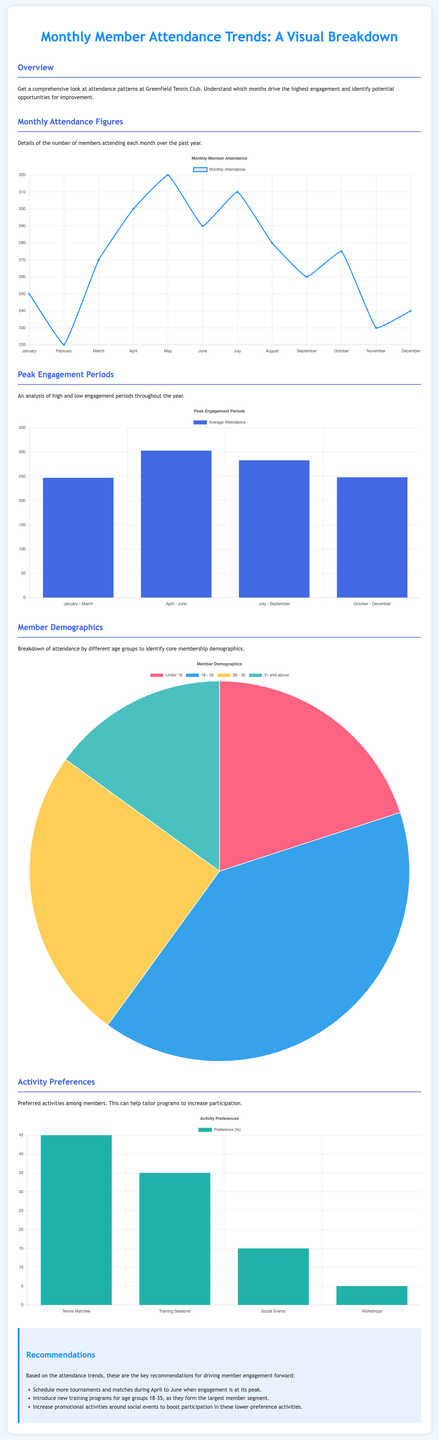What was the highest attendance month? The highest attendance month can be seen in the Monthly Attendance Chart, which shows that June had the highest number of members attending with a figure of 320.
Answer: June What is the average attendance for the period April to June? The average attendance during the April to June period is shown in the Peak Engagement Periods chart, which indicates an average of 303 members attending.
Answer: 303 Which age group has the largest attendance? The demographics chart indicates that the 18 - 35 age group has the largest attendance, with a percentage of 40.
Answer: 18 - 35 What is the minimum attendance level recorded in a month? The Monthly Attendance chart shows that the minimum attendance level recorded in a month was in February, with an attendance of 220 members.
Answer: 220 What percentage of members prefer tennis matches? According to the Activity Preferences chart, 45% of members prefer tennis matches as their activity.
Answer: 45% What was the attendance figure for November? The Monthly Attendance chart records that the attendance for November was 230 members.
Answer: 230 How many members fall into the '51 and above' age category? The demographics pie chart shows that 15% of members are in the '51 and above' age category.
Answer: 15% Which type of activity had the least preference among members? The Activity Preferences chart reveals that workshops had the least preference, accounting for only 5% of member interests.
Answer: Workshops What is recommended to increase participation during low-engagement months? The recommendations section suggests increasing promotional activities around social events to boost participation during lower-preference activities.
Answer: Increase promotional activities 